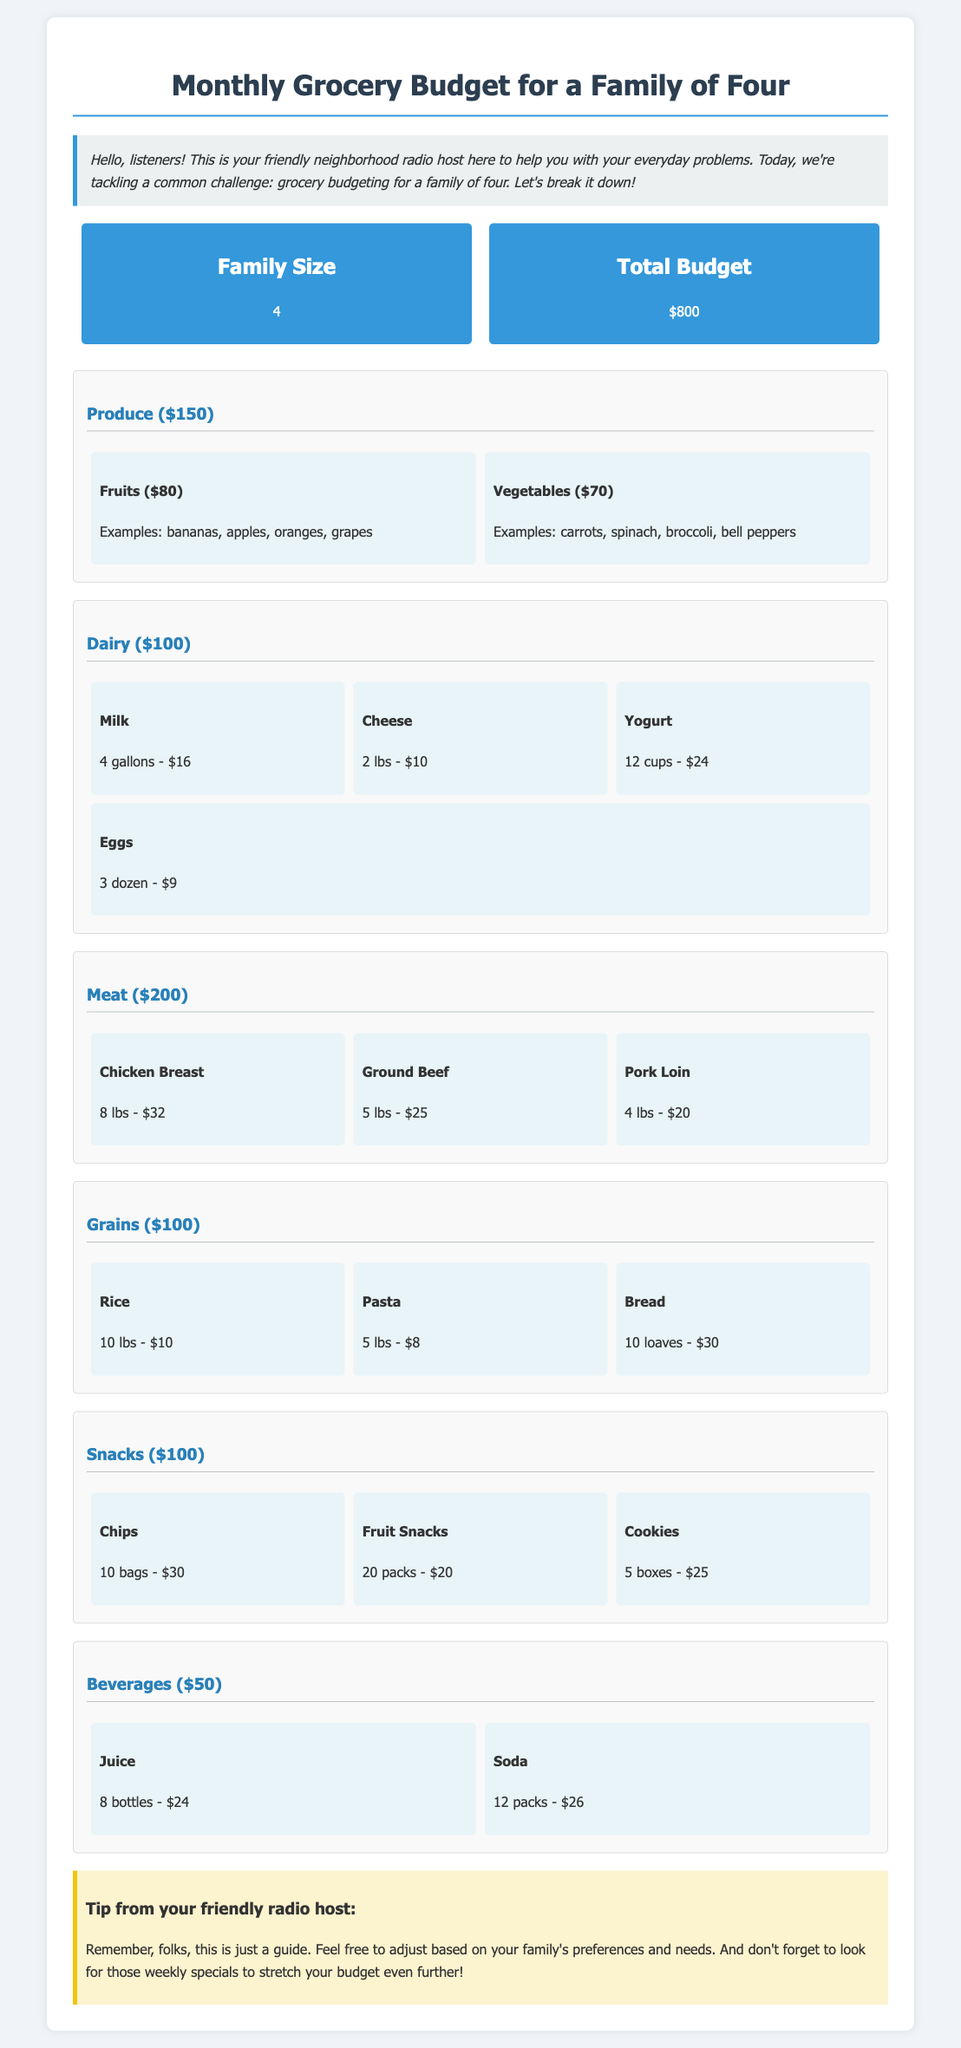what is the total grocery budget? The total grocery budget for the family of four is specified in the document as $800.
Answer: $800 how many people does the budget cater to? The budget overview states the family size, which is 4.
Answer: 4 how much is allocated for produce? The document specifies that the budget for produce is $150.
Answer: $150 how many gallons of milk are included in the dairy section? The dairy section lists that 4 gallons of milk are included in the budget.
Answer: 4 gallons what is the total budget for snacks? The budget includes $100 allocated for snacks.
Answer: $100 what are some examples of fruits listed under produce? The document provides examples of fruits, which include bananas, apples, oranges, and grapes.
Answer: bananas, apples, oranges, grapes how much does the family budget for beverages? The beverages category indicates a budget of $50 for this section.
Answer: $50 how many pounds of chicken breast are in the meat section? The meat section specifies that there are 8 pounds of chicken breast included.
Answer: 8 lbs what is the cost of eggs in the dairy section? The document states that the cost for eggs is $9 for 3 dozen.
Answer: $9 how much total is spent on grains? The budget allocated for grains totals $100 according to the document.
Answer: $100 